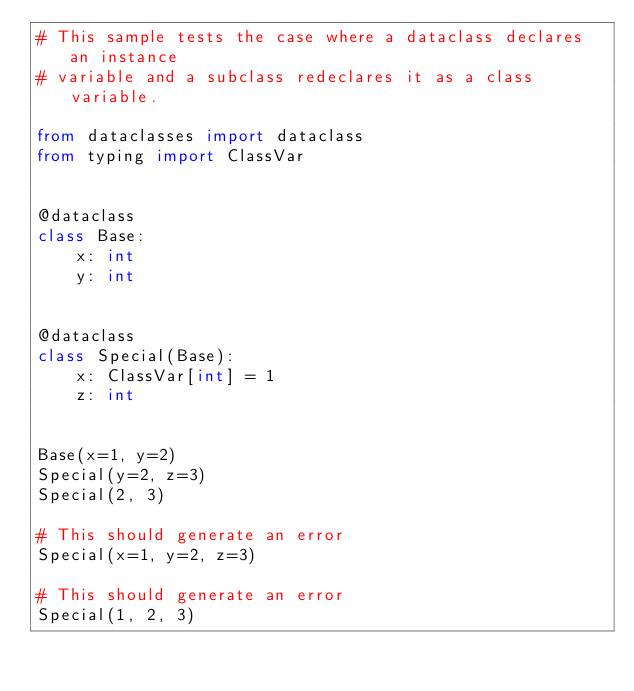<code> <loc_0><loc_0><loc_500><loc_500><_Python_># This sample tests the case where a dataclass declares an instance
# variable and a subclass redeclares it as a class variable.

from dataclasses import dataclass
from typing import ClassVar


@dataclass
class Base:
    x: int
    y: int


@dataclass
class Special(Base):
    x: ClassVar[int] = 1
    z: int


Base(x=1, y=2)
Special(y=2, z=3)
Special(2, 3)

# This should generate an error
Special(x=1, y=2, z=3)

# This should generate an error
Special(1, 2, 3)
</code> 